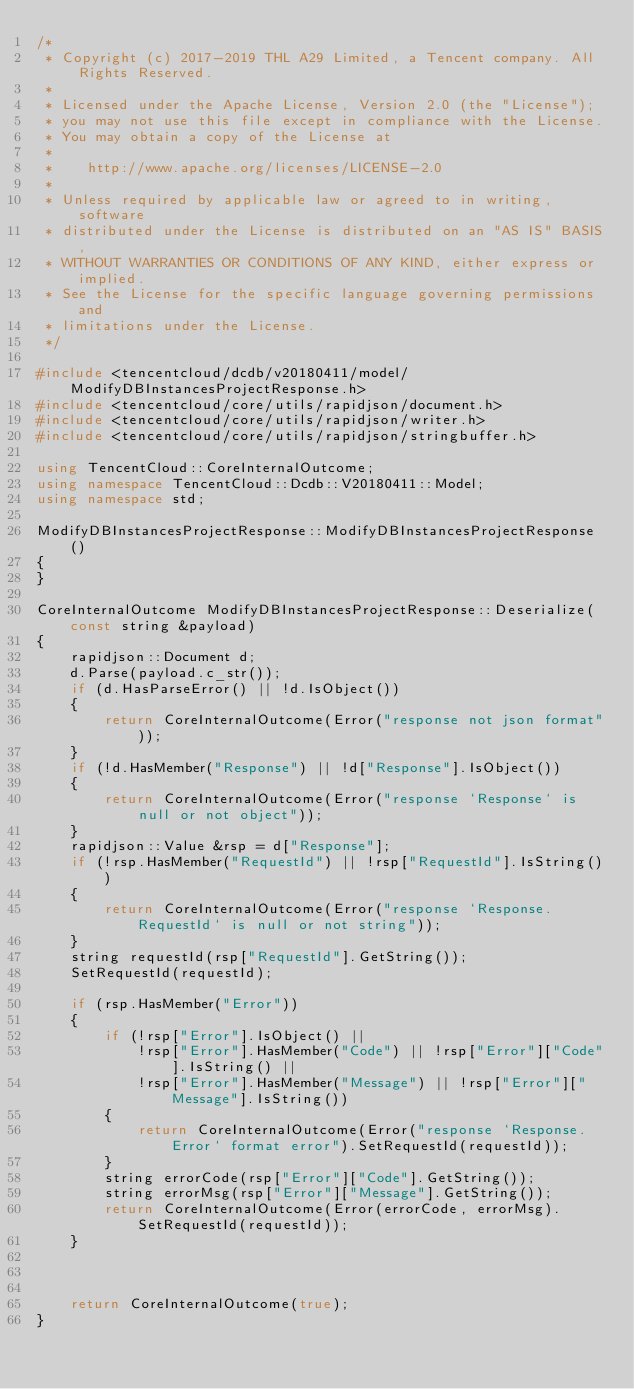<code> <loc_0><loc_0><loc_500><loc_500><_C++_>/*
 * Copyright (c) 2017-2019 THL A29 Limited, a Tencent company. All Rights Reserved.
 *
 * Licensed under the Apache License, Version 2.0 (the "License");
 * you may not use this file except in compliance with the License.
 * You may obtain a copy of the License at
 *
 *    http://www.apache.org/licenses/LICENSE-2.0
 *
 * Unless required by applicable law or agreed to in writing, software
 * distributed under the License is distributed on an "AS IS" BASIS,
 * WITHOUT WARRANTIES OR CONDITIONS OF ANY KIND, either express or implied.
 * See the License for the specific language governing permissions and
 * limitations under the License.
 */

#include <tencentcloud/dcdb/v20180411/model/ModifyDBInstancesProjectResponse.h>
#include <tencentcloud/core/utils/rapidjson/document.h>
#include <tencentcloud/core/utils/rapidjson/writer.h>
#include <tencentcloud/core/utils/rapidjson/stringbuffer.h>

using TencentCloud::CoreInternalOutcome;
using namespace TencentCloud::Dcdb::V20180411::Model;
using namespace std;

ModifyDBInstancesProjectResponse::ModifyDBInstancesProjectResponse()
{
}

CoreInternalOutcome ModifyDBInstancesProjectResponse::Deserialize(const string &payload)
{
    rapidjson::Document d;
    d.Parse(payload.c_str());
    if (d.HasParseError() || !d.IsObject())
    {
        return CoreInternalOutcome(Error("response not json format"));
    }
    if (!d.HasMember("Response") || !d["Response"].IsObject())
    {
        return CoreInternalOutcome(Error("response `Response` is null or not object"));
    }
    rapidjson::Value &rsp = d["Response"];
    if (!rsp.HasMember("RequestId") || !rsp["RequestId"].IsString())
    {
        return CoreInternalOutcome(Error("response `Response.RequestId` is null or not string"));
    }
    string requestId(rsp["RequestId"].GetString());
    SetRequestId(requestId);

    if (rsp.HasMember("Error"))
    {
        if (!rsp["Error"].IsObject() ||
            !rsp["Error"].HasMember("Code") || !rsp["Error"]["Code"].IsString() ||
            !rsp["Error"].HasMember("Message") || !rsp["Error"]["Message"].IsString())
        {
            return CoreInternalOutcome(Error("response `Response.Error` format error").SetRequestId(requestId));
        }
        string errorCode(rsp["Error"]["Code"].GetString());
        string errorMsg(rsp["Error"]["Message"].GetString());
        return CoreInternalOutcome(Error(errorCode, errorMsg).SetRequestId(requestId));
    }



    return CoreInternalOutcome(true);
}



</code> 